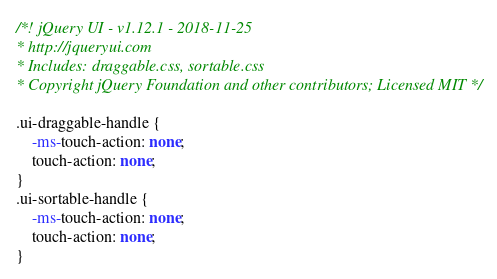Convert code to text. <code><loc_0><loc_0><loc_500><loc_500><_CSS_>/*! jQuery UI - v1.12.1 - 2018-11-25
* http://jqueryui.com
* Includes: draggable.css, sortable.css
* Copyright jQuery Foundation and other contributors; Licensed MIT */

.ui-draggable-handle {
	-ms-touch-action: none;
	touch-action: none;
}
.ui-sortable-handle {
	-ms-touch-action: none;
	touch-action: none;
}
</code> 